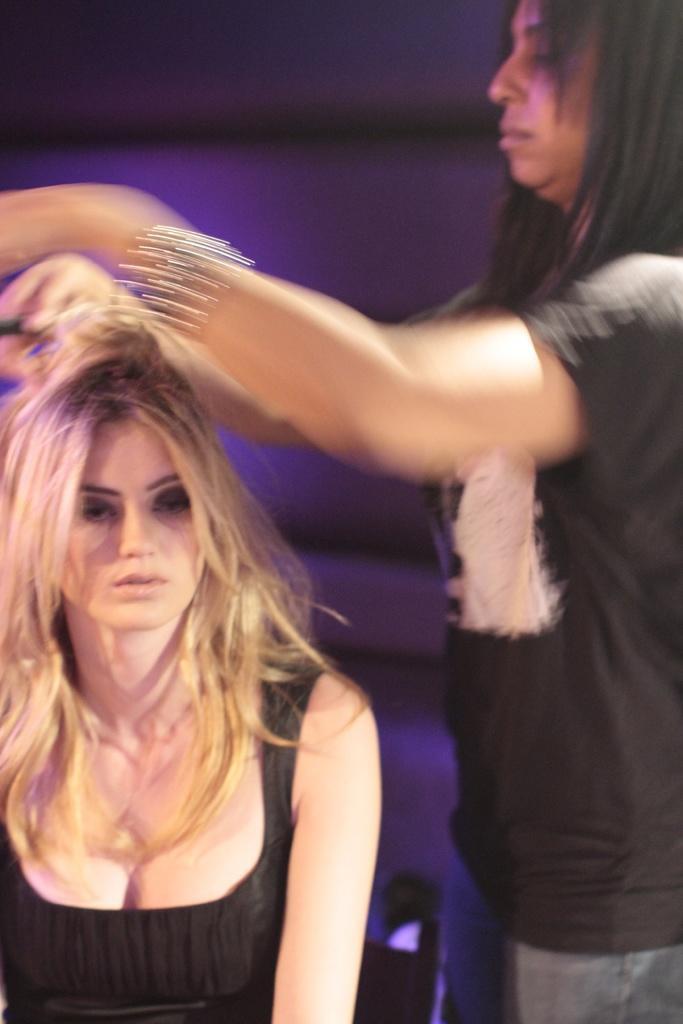Can you describe this image briefly? In this picture we can see two women and in the background we can see it is blurry. 